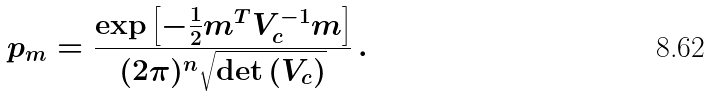<formula> <loc_0><loc_0><loc_500><loc_500>p _ { m } = \frac { \exp { \left [ - \frac { 1 } { 2 } m ^ { T } V _ { c } ^ { - 1 } m \right ] } } { ( 2 \pi ) ^ { n } \sqrt { \det { ( V _ { c } ) } } } \, .</formula> 